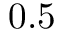<formula> <loc_0><loc_0><loc_500><loc_500>0 . 5</formula> 